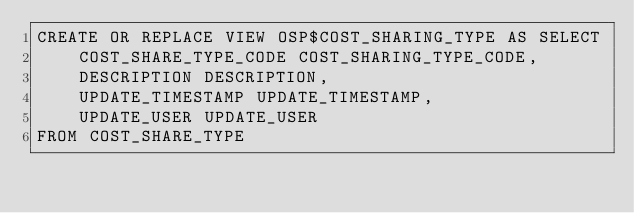Convert code to text. <code><loc_0><loc_0><loc_500><loc_500><_SQL_>CREATE OR REPLACE VIEW OSP$COST_SHARING_TYPE AS SELECT 
	COST_SHARE_TYPE_CODE COST_SHARING_TYPE_CODE,
	DESCRIPTION DESCRIPTION,
	UPDATE_TIMESTAMP UPDATE_TIMESTAMP, 
	UPDATE_USER UPDATE_USER
FROM COST_SHARE_TYPE</code> 